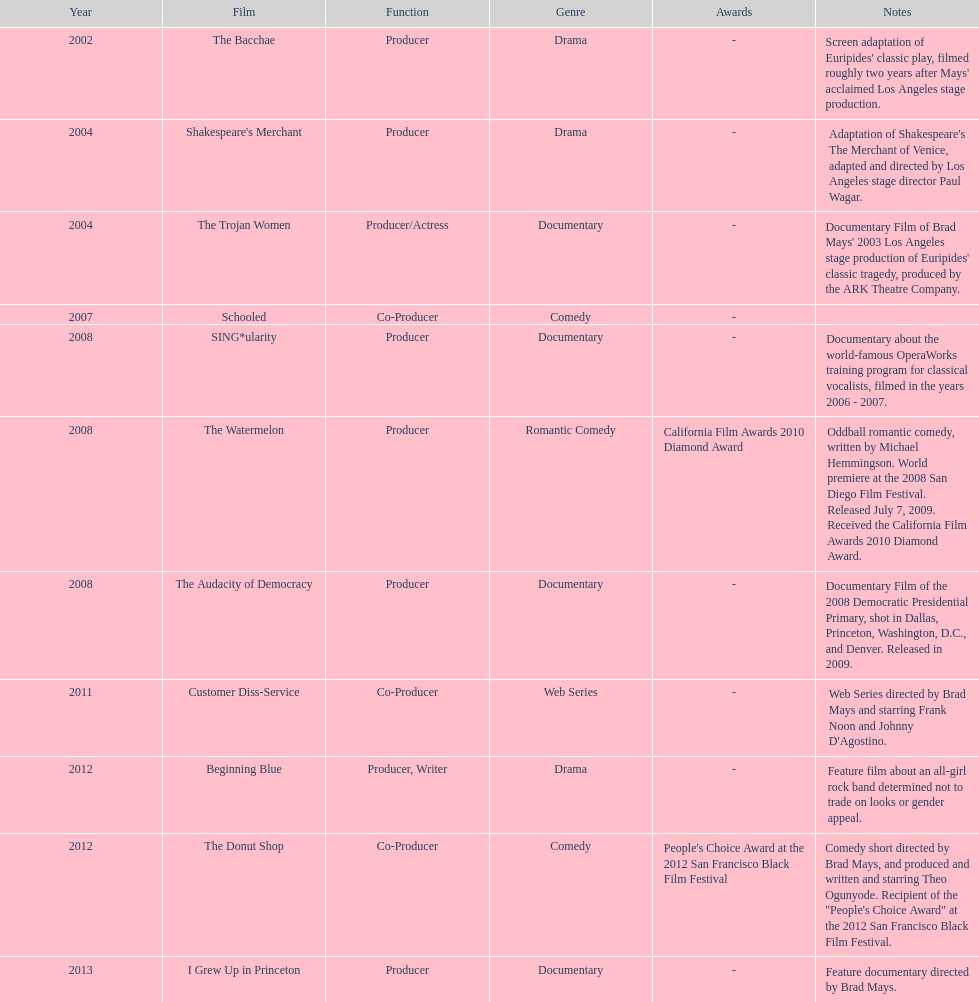Which year was there at least three movies? 2008. 